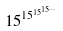<formula> <loc_0><loc_0><loc_500><loc_500>1 5 ^ { 1 5 ^ { 1 5 ^ { 1 5 ^ { \dots } } } }</formula> 